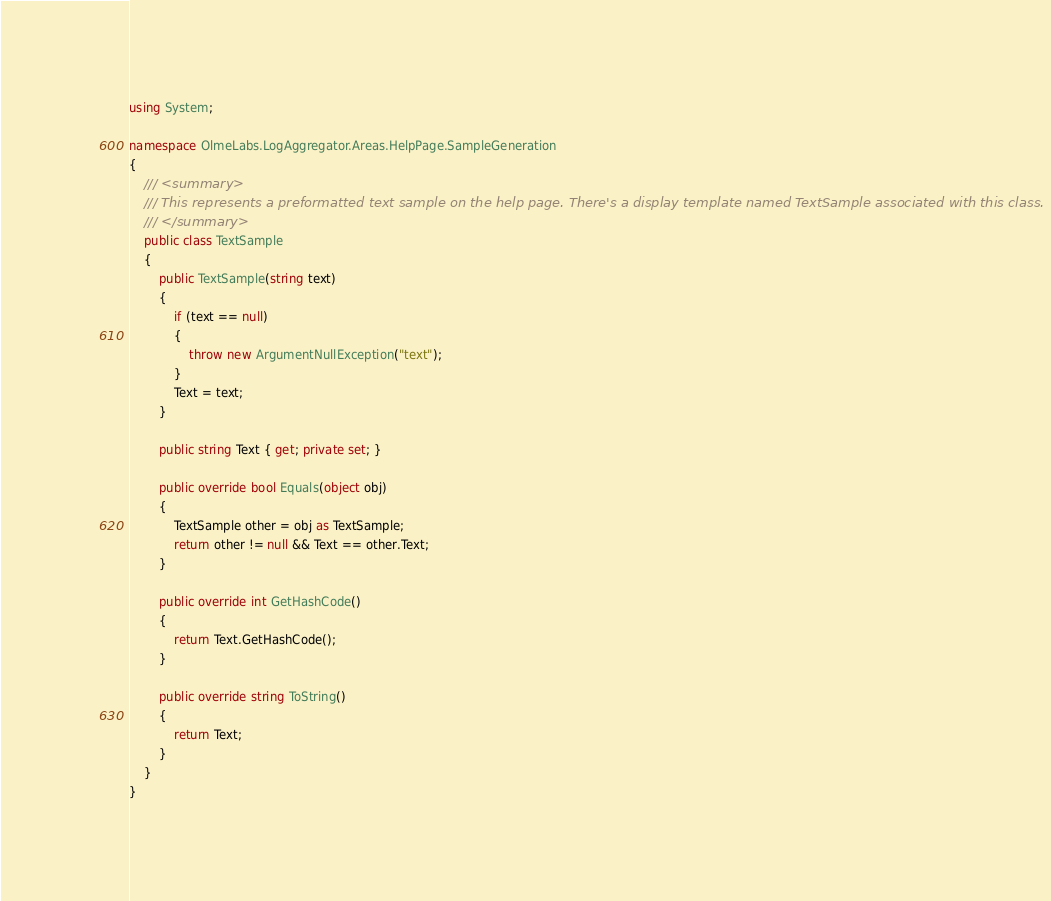Convert code to text. <code><loc_0><loc_0><loc_500><loc_500><_C#_>using System;

namespace OlmeLabs.LogAggregator.Areas.HelpPage.SampleGeneration
{
    /// <summary>
    /// This represents a preformatted text sample on the help page. There's a display template named TextSample associated with this class.
    /// </summary>
    public class TextSample
    {
        public TextSample(string text)
        {
            if (text == null)
            {
                throw new ArgumentNullException("text");
            }
            Text = text;
        }

        public string Text { get; private set; }

        public override bool Equals(object obj)
        {
            TextSample other = obj as TextSample;
            return other != null && Text == other.Text;
        }

        public override int GetHashCode()
        {
            return Text.GetHashCode();
        }

        public override string ToString()
        {
            return Text;
        }
    }
}</code> 